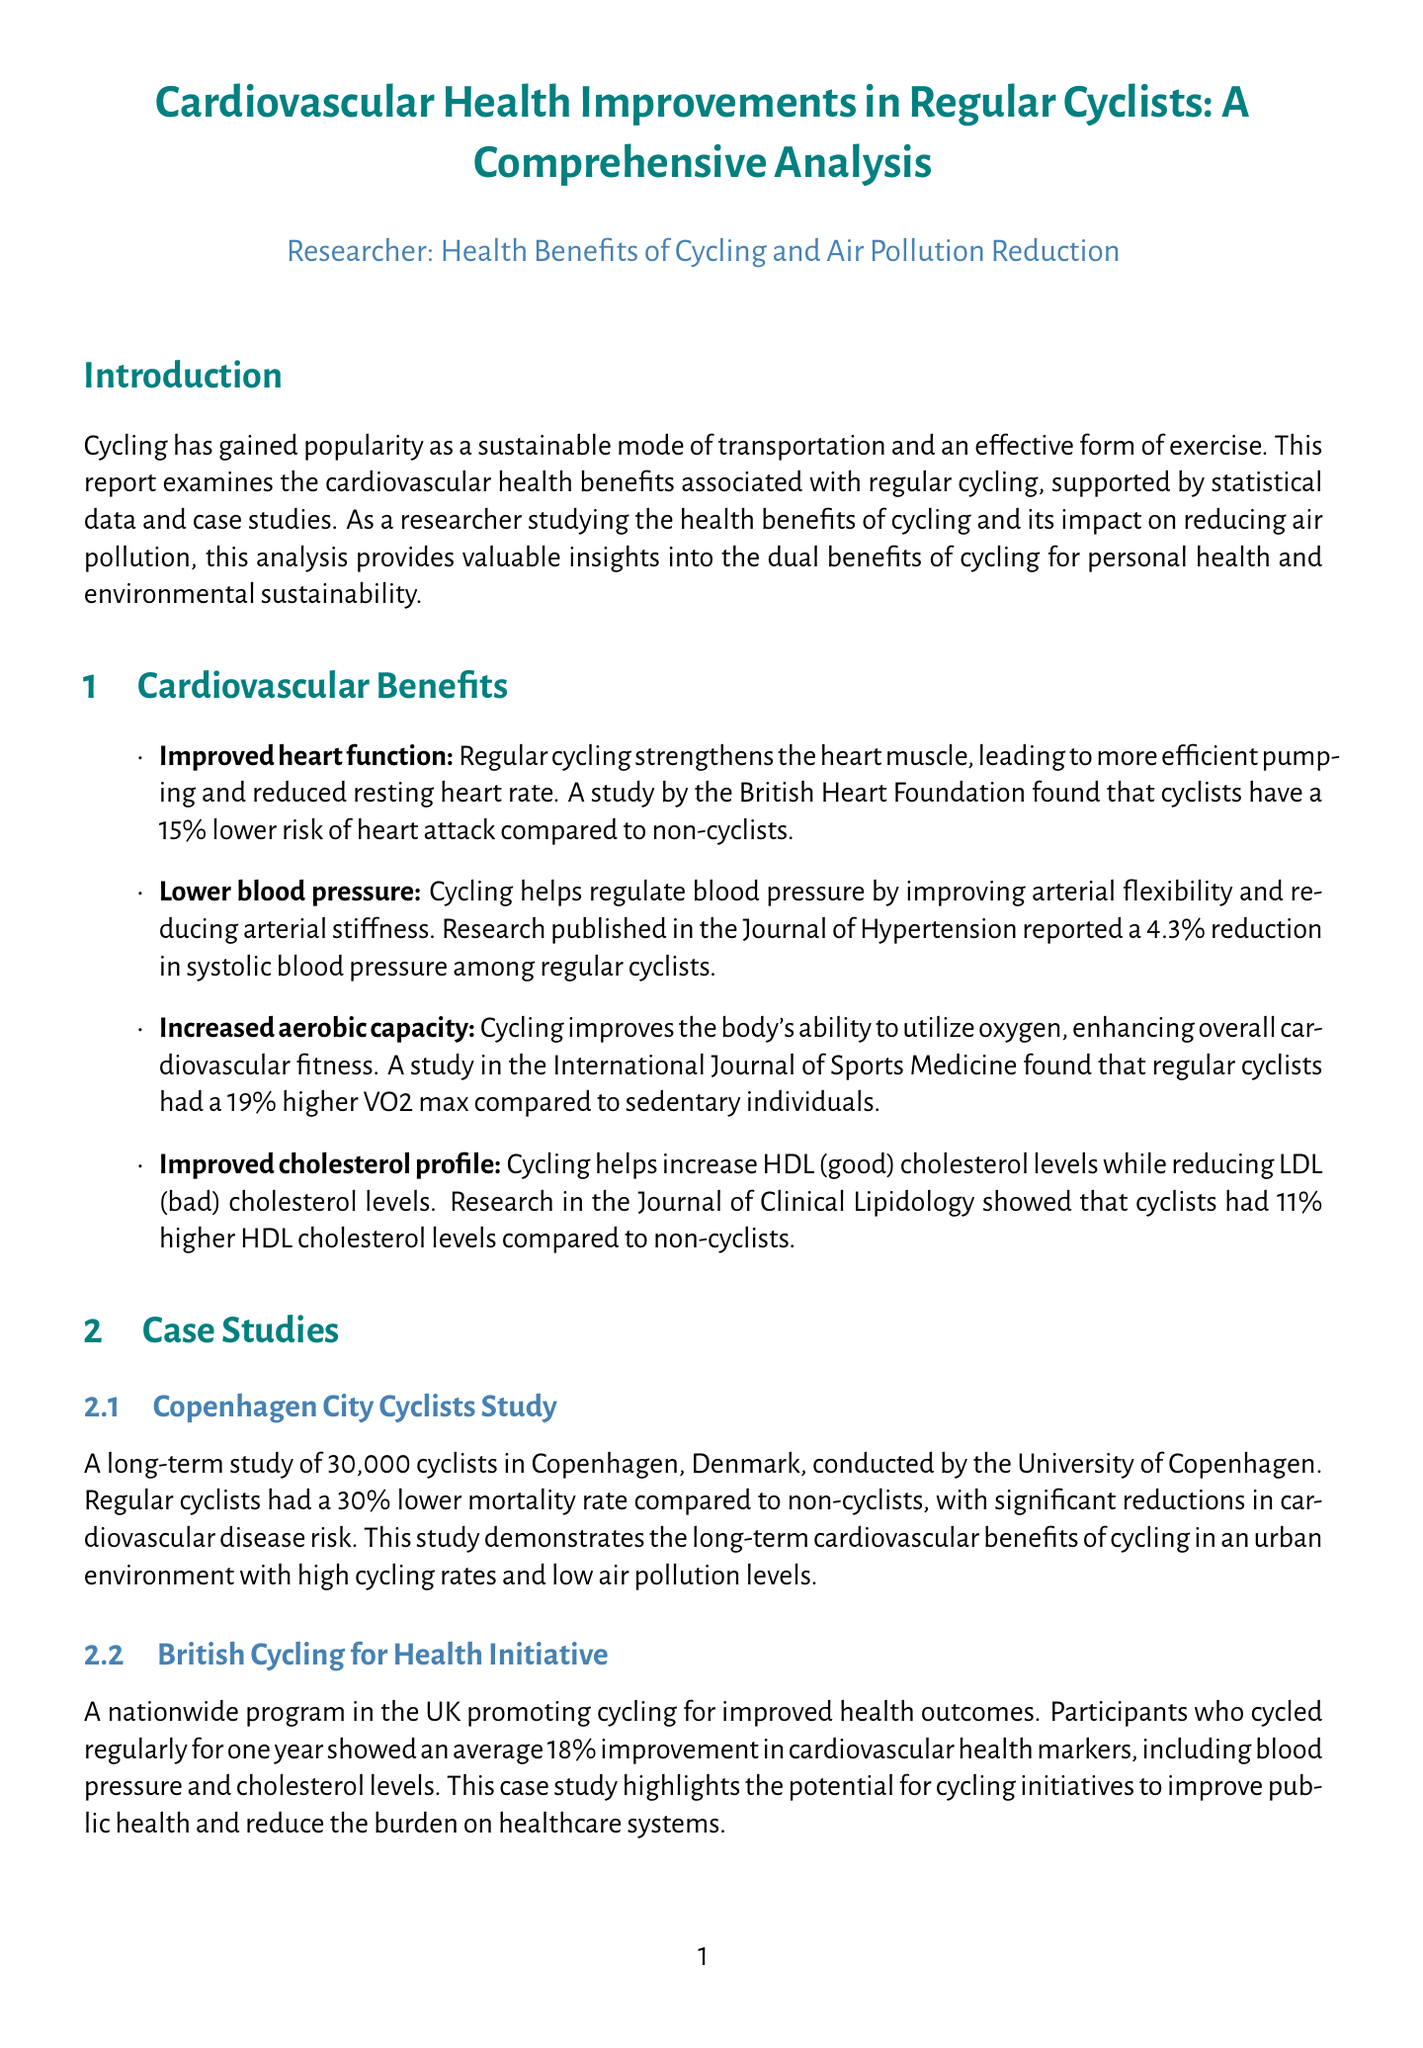what is the title of the report? The title provides the main subject of the document, which is focused on cardiovascular health benefits in regular cyclists.
Answer: Cardiovascular Health Improvements in Regular Cyclists: A Comprehensive Analysis what percentage lower is the heart attack risk for cyclists compared to non-cyclists? This information is provided in the section discussing cardiovascular benefits of cycling, specifically in relation to heart attack risk.
Answer: 15% what is the average reduction in systolic blood pressure among regular cyclists? The document cites specific research findings regarding blood pressure improvement related to cycling.
Answer: 4.3% how much higher is the VO2 max in regular cyclists compared to sedentary individuals? This statistic reflects the increased aerobic capacity achieved through regular cycling, as mentioned in the report.
Answer: 19% what was the mortality rate reduction found in the Copenhagen City Cyclists Study? The findings of this case study highlight significant health benefits for regular cyclists in terms of mortality rates.
Answer: 30% which journal reported an 11% increase in HDL cholesterol levels among cyclists? This detail is found in the section detailing cholesterol improvements related to cycling.
Answer: Journal of Clinical Lipidology what is the potential reduction in CO2 emissions if bicycle use increases in European countries? This statistic illustrates cycling's impact on air pollution and environmental sustainability, as discussed in the air pollution impact section.
Answer: 55 million tons what percentage improvement in cardiovascular health markers was observed in participants of the British Cycling for Health Initiative? This data reflects the positive health outcomes associated with a cycling initiative as discussed in the case studies.
Answer: 18% what does the report suggest is needed for further research? The conclusion section indicates areas where additional research is necessary to further understand cycling's benefits.
Answer: Long-term impact of cycling on cardiovascular health 